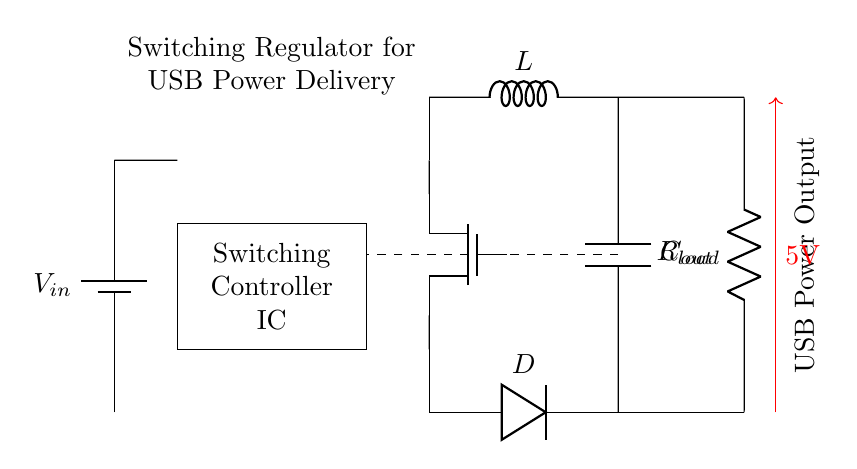What is the input voltage of this circuit? The input voltage is represented by the label V in the circuit diagram, which indicates the source providing the necessary voltage to the regulator.
Answer: V in What type of component is used for switching in this regulator? The switching component is indicated by the label "Switching Controller IC," which is a specific integrated circuit designed for regulation by controlling the on/off states of the switching action.
Answer: Switching Controller IC What is the role of the inductor represented by L? The inductor, labeled L, is used in the circuit to store energy temporarily during the switching operation and helps to smooth out the output current, contributing to the stable voltage regulation function.
Answer: Energy storage What is the output voltage of this circuit? The output voltage is directly labeled as 5V in the circuit, indicating the regulated voltage provided to the load across the output terminals.
Answer: 5V How many passive components are used in this circuit? The passive components are the inductor (L), diode (D), and output capacitor (Cout). Thus, we have three passive components contributing to the circuit's functionality.
Answer: Three What is the purpose of the diode D in this circuit? The diode labeled D serves as a rectifying component, ensuring current flows in one direction and providing protection by preventing reverse current, which would otherwise damage the circuit during switching operations.
Answer: Rectification What does the dashed line in the circuit diagram indicate? The dashed line represents the feedback connection, which is crucial in regulating the output voltage by feeding back a portion of the output voltage to the controller to adjust its operation accordingly.
Answer: Feedback connection 